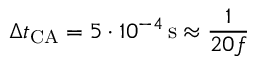<formula> <loc_0><loc_0><loc_500><loc_500>\Delta t _ { C A } = 5 \cdot 1 0 ^ { - 4 } \, s \approx \frac { 1 } { 2 0 f }</formula> 